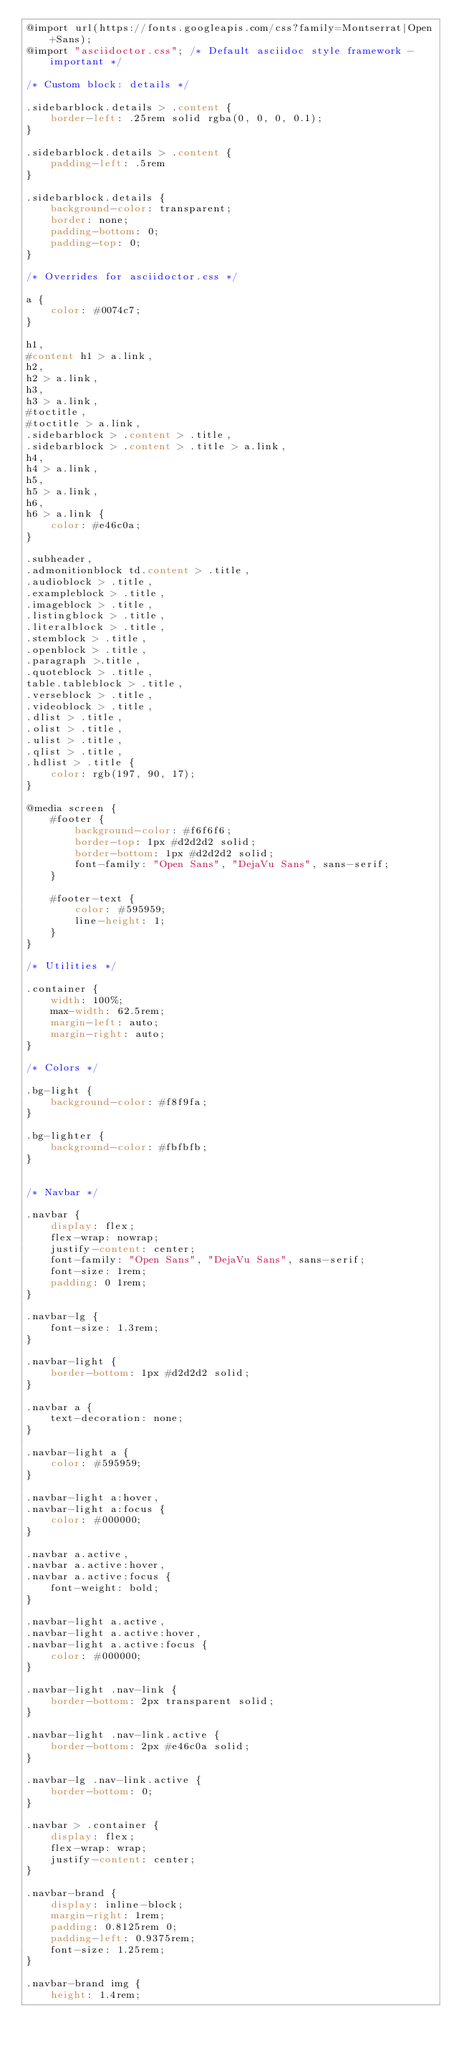<code> <loc_0><loc_0><loc_500><loc_500><_CSS_>@import url(https://fonts.googleapis.com/css?family=Montserrat|Open+Sans);
@import "asciidoctor.css"; /* Default asciidoc style framework - important */

/* Custom block: details */

.sidebarblock.details > .content {
    border-left: .25rem solid rgba(0, 0, 0, 0.1);
}

.sidebarblock.details > .content {
    padding-left: .5rem
}

.sidebarblock.details {
    background-color: transparent;
    border: none;
    padding-bottom: 0;
    padding-top: 0;
}

/* Overrides for asciidoctor.css */

a {
    color: #0074c7;
}

h1,
#content h1 > a.link,
h2,
h2 > a.link,
h3,
h3 > a.link,
#toctitle,
#toctitle > a.link,
.sidebarblock > .content > .title,
.sidebarblock > .content > .title > a.link,
h4,
h4 > a.link,
h5,
h5 > a.link,
h6,
h6 > a.link {
    color: #e46c0a;
}

.subheader,
.admonitionblock td.content > .title,
.audioblock > .title,
.exampleblock > .title,
.imageblock > .title,
.listingblock > .title,
.literalblock > .title,
.stemblock > .title,
.openblock > .title,
.paragraph >.title,
.quoteblock > .title,
table.tableblock > .title,
.verseblock > .title,
.videoblock > .title,
.dlist > .title,
.olist > .title,
.ulist > .title,
.qlist > .title,
.hdlist > .title {
    color: rgb(197, 90, 17);
}

@media screen {
    #footer {
        background-color: #f6f6f6;
        border-top: 1px #d2d2d2 solid;
        border-bottom: 1px #d2d2d2 solid;
        font-family: "Open Sans", "DejaVu Sans", sans-serif;
    }

    #footer-text {
        color: #595959;
        line-height: 1;
    }
}

/* Utilities */

.container {
    width: 100%;
    max-width: 62.5rem;
    margin-left: auto;
    margin-right: auto;
}

/* Colors */

.bg-light {
    background-color: #f8f9fa;
}

.bg-lighter {
    background-color: #fbfbfb;
}


/* Navbar */

.navbar {
    display: flex;
    flex-wrap: nowrap;
    justify-content: center;
    font-family: "Open Sans", "DejaVu Sans", sans-serif;
    font-size: 1rem;
    padding: 0 1rem;
}

.navbar-lg {
    font-size: 1.3rem;
}

.navbar-light {
    border-bottom: 1px #d2d2d2 solid;
}

.navbar a {
    text-decoration: none;
}

.navbar-light a {
    color: #595959;
}

.navbar-light a:hover,
.navbar-light a:focus {
    color: #000000;
}

.navbar a.active,
.navbar a.active:hover,
.navbar a.active:focus {
    font-weight: bold;
}

.navbar-light a.active,
.navbar-light a.active:hover,
.navbar-light a.active:focus {
    color: #000000;
}

.navbar-light .nav-link {
    border-bottom: 2px transparent solid;
}

.navbar-light .nav-link.active {
    border-bottom: 2px #e46c0a solid;
}

.navbar-lg .nav-link.active {
    border-bottom: 0;
}

.navbar > .container {
    display: flex;
    flex-wrap: wrap;
    justify-content: center;
}

.navbar-brand {
    display: inline-block;
    margin-right: 1rem;
    padding: 0.8125rem 0;
    padding-left: 0.9375rem;
    font-size: 1.25rem;
}

.navbar-brand img {
    height: 1.4rem;</code> 